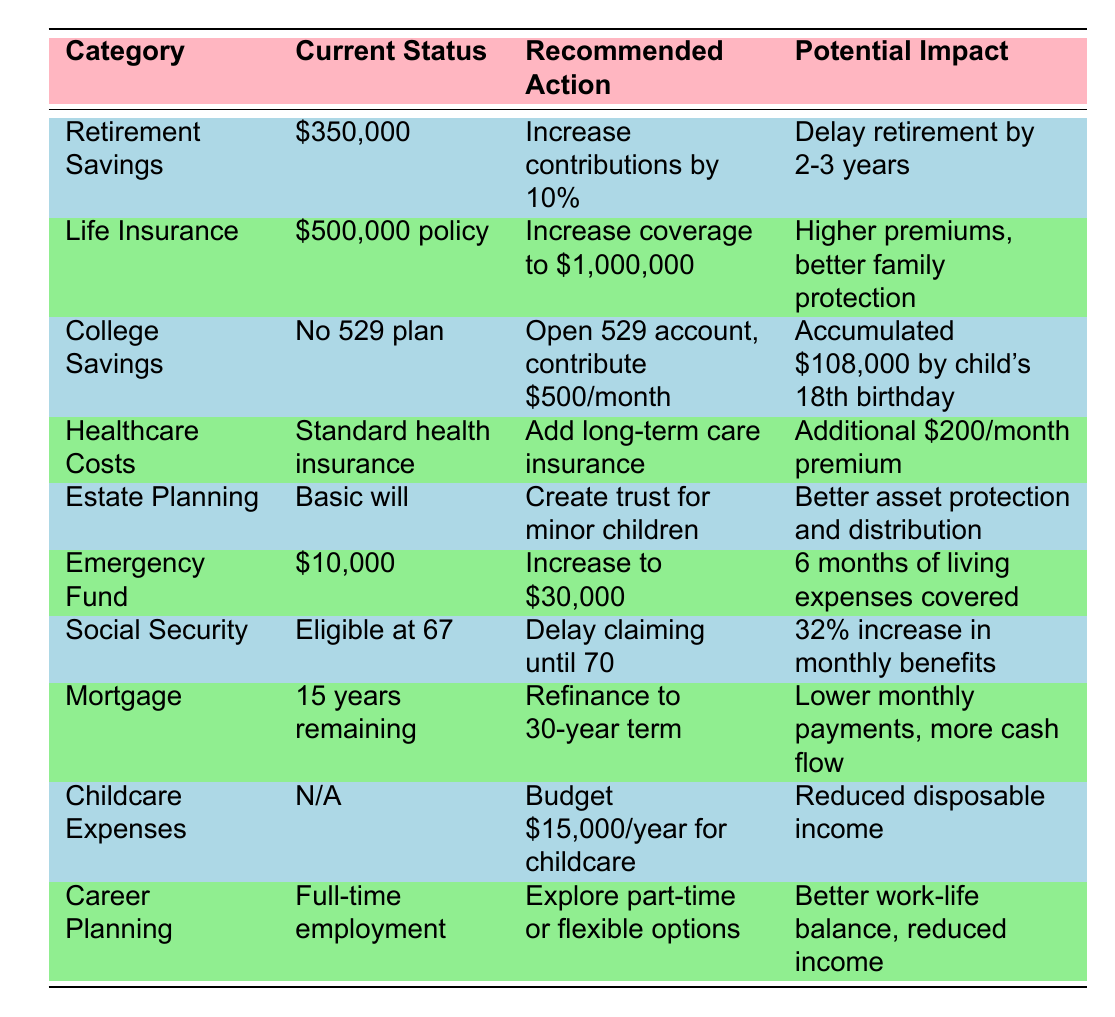What is the current status of retirement savings? The table shows that the current status of retirement savings is $350,000.
Answer: $350,000 What recommended action is suggested for life insurance coverage? The recommended action for life insurance coverage is to increase it to $1,000,000.
Answer: Increase to $1,000,000 How much is suggested to be budgeted annually for childcare expenses? The table recommends budgeting $15,000 per year for childcare expenses.
Answer: $15,000 What is the potential impact of increasing the emergency fund to $30,000? Increasing the emergency fund to $30,000 would cover six months of living expenses.
Answer: 6 months of living expenses Is there a recommendation related to social security claims? Yes, the recommendation is to delay claiming social security benefits until age 70.
Answer: Yes If I delay my social security claims until 70, what will be the potential impact? Delaying social security claims until age 70 could result in a 32% increase in monthly benefits.
Answer: 32% increase What is the potential impact of opening a 529 account for college savings? The potential impact of opening a 529 account and contributing $500/month is an accumulation of $108,000 by the child's 18th birthday.
Answer: $108,000 What is the difference between the current life insurance policy and the recommended coverage? The current life insurance policy is $500,000, whereas the recommended coverage is $1,000,000, which is an increase of $500,000.
Answer: $500,000 increase How long will the mortgage term potentially extend if refinanced to a 30-year term? If refinanced to a 30-year term, the remaining mortgage duration will extend to an additional 15 years.
Answer: 15 years What is the total amount to be gathered from childcare and college savings if both actions are taken? The total gathered from budgeting for childcare and starting a 529 account would be $15,000 (annual childcare expense) multiplied by the number of years until the child is 18 and $108,000 from the 529 account. Since childcare will likely be needed only for 18 years, the total would be $15,000 x 18 + $108,000 = $378,000.
Answer: $378,000 